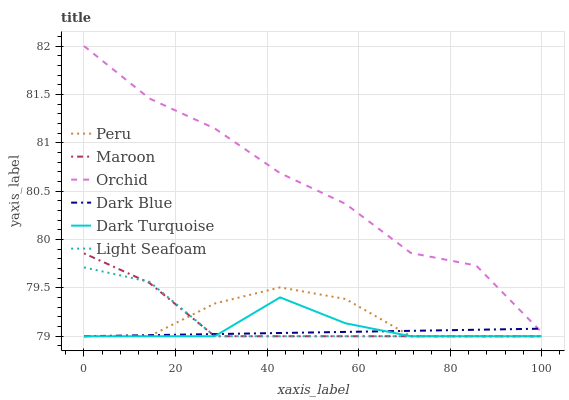Does Dark Blue have the minimum area under the curve?
Answer yes or no. Yes. Does Orchid have the maximum area under the curve?
Answer yes or no. Yes. Does Maroon have the minimum area under the curve?
Answer yes or no. No. Does Maroon have the maximum area under the curve?
Answer yes or no. No. Is Dark Blue the smoothest?
Answer yes or no. Yes. Is Orchid the roughest?
Answer yes or no. Yes. Is Maroon the smoothest?
Answer yes or no. No. Is Maroon the roughest?
Answer yes or no. No. Does Dark Turquoise have the lowest value?
Answer yes or no. Yes. Does Orchid have the lowest value?
Answer yes or no. No. Does Orchid have the highest value?
Answer yes or no. Yes. Does Maroon have the highest value?
Answer yes or no. No. Is Dark Turquoise less than Orchid?
Answer yes or no. Yes. Is Orchid greater than Light Seafoam?
Answer yes or no. Yes. Does Dark Turquoise intersect Dark Blue?
Answer yes or no. Yes. Is Dark Turquoise less than Dark Blue?
Answer yes or no. No. Is Dark Turquoise greater than Dark Blue?
Answer yes or no. No. Does Dark Turquoise intersect Orchid?
Answer yes or no. No. 